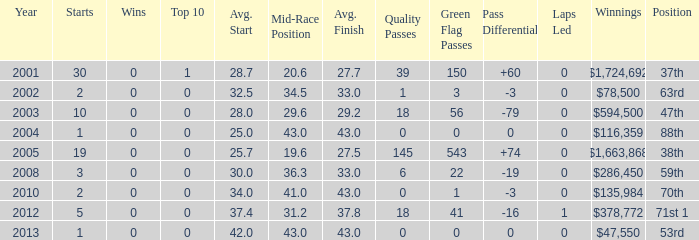How many wins for average start less than 25? 0.0. 